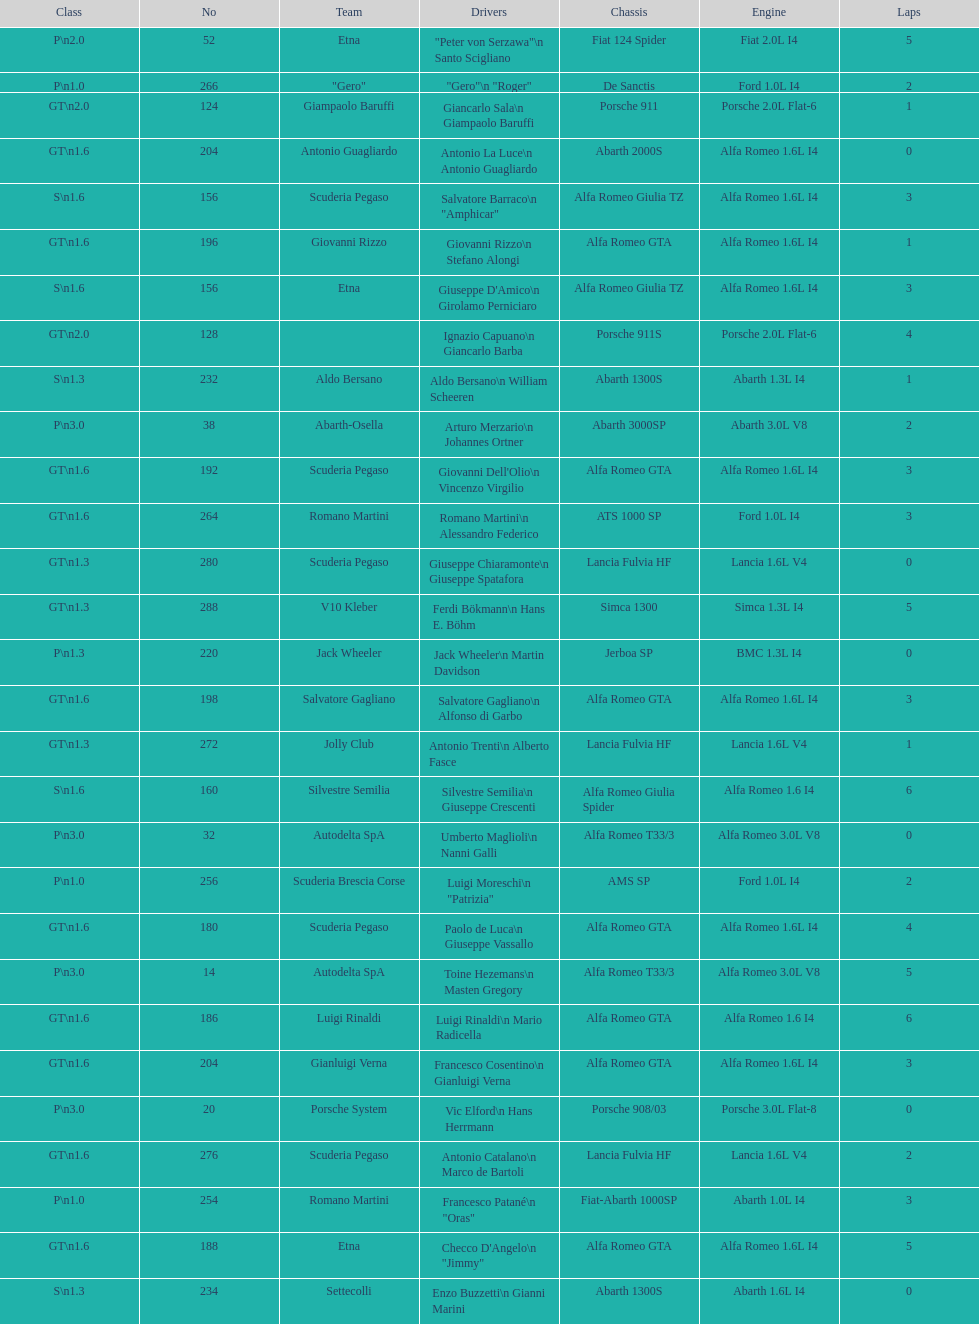What is the chassis positioned between simca 1300 and alfa romeo gta? Porsche 911S. 